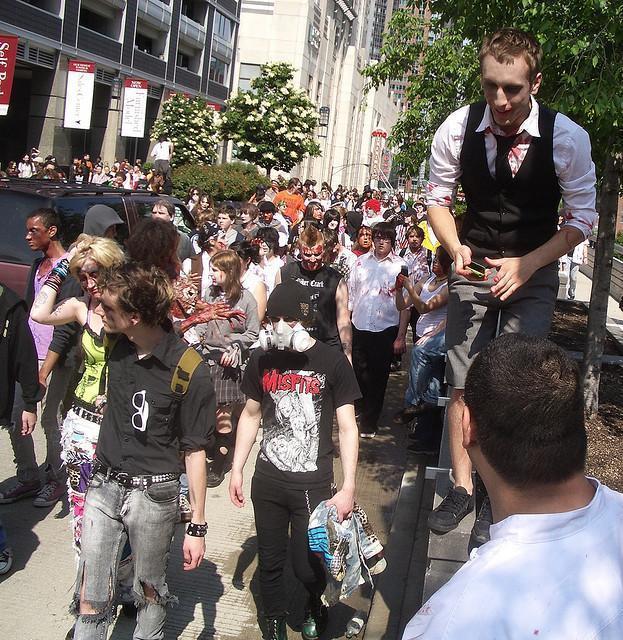How many people can you see?
Give a very brief answer. 10. 